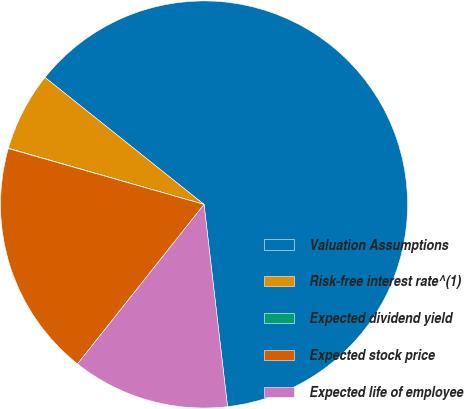<chart> <loc_0><loc_0><loc_500><loc_500><pie_chart><fcel>Valuation Assumptions<fcel>Risk-free interest rate^(1)<fcel>Expected dividend yield<fcel>Expected stock price<fcel>Expected life of employee<nl><fcel>62.43%<fcel>6.27%<fcel>0.03%<fcel>18.75%<fcel>12.51%<nl></chart> 